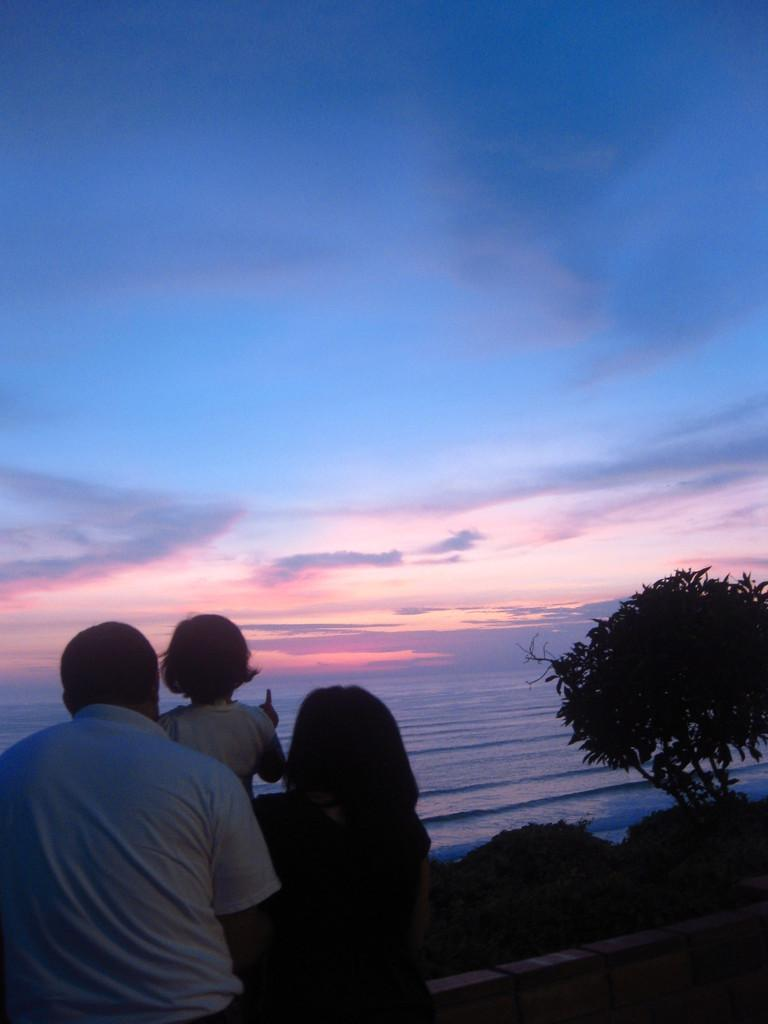How many people are present in the image? There are three people in the image: a man, a woman, and a child. What are the people in the image wearing? The man, woman, and child are wearing clothes. What can be seen in the background of the image? There is water, a tree, a plant, and the sky visible in the image. What type of gold can be seen in the mine in the image? There is no mine or gold present in the image; it features a man, woman, and child in a natural setting with water, trees, and plants. 